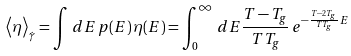<formula> <loc_0><loc_0><loc_500><loc_500>\left < \eta \right > _ { \dot { \gamma } } = \int \, d E \, p ( E ) \, \eta ( E ) = \int _ { 0 } ^ { \infty } \, d E \frac { T - T _ { g } } { T T _ { g } } \, e ^ { - \frac { T - 2 T _ { g } } { T T _ { g } } E }</formula> 